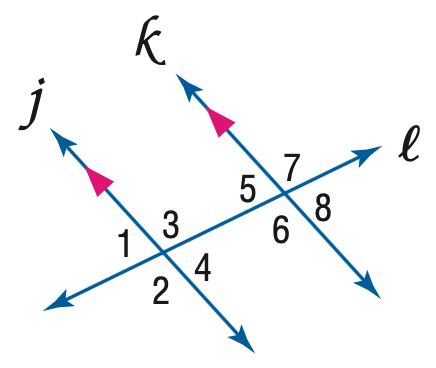Question: Find y if m \angle 5 = 68 and m \angle 3 = 3 y - 2.
Choices:
A. 22
B. 23.3
C. 38
D. 82
Answer with the letter. Answer: C 